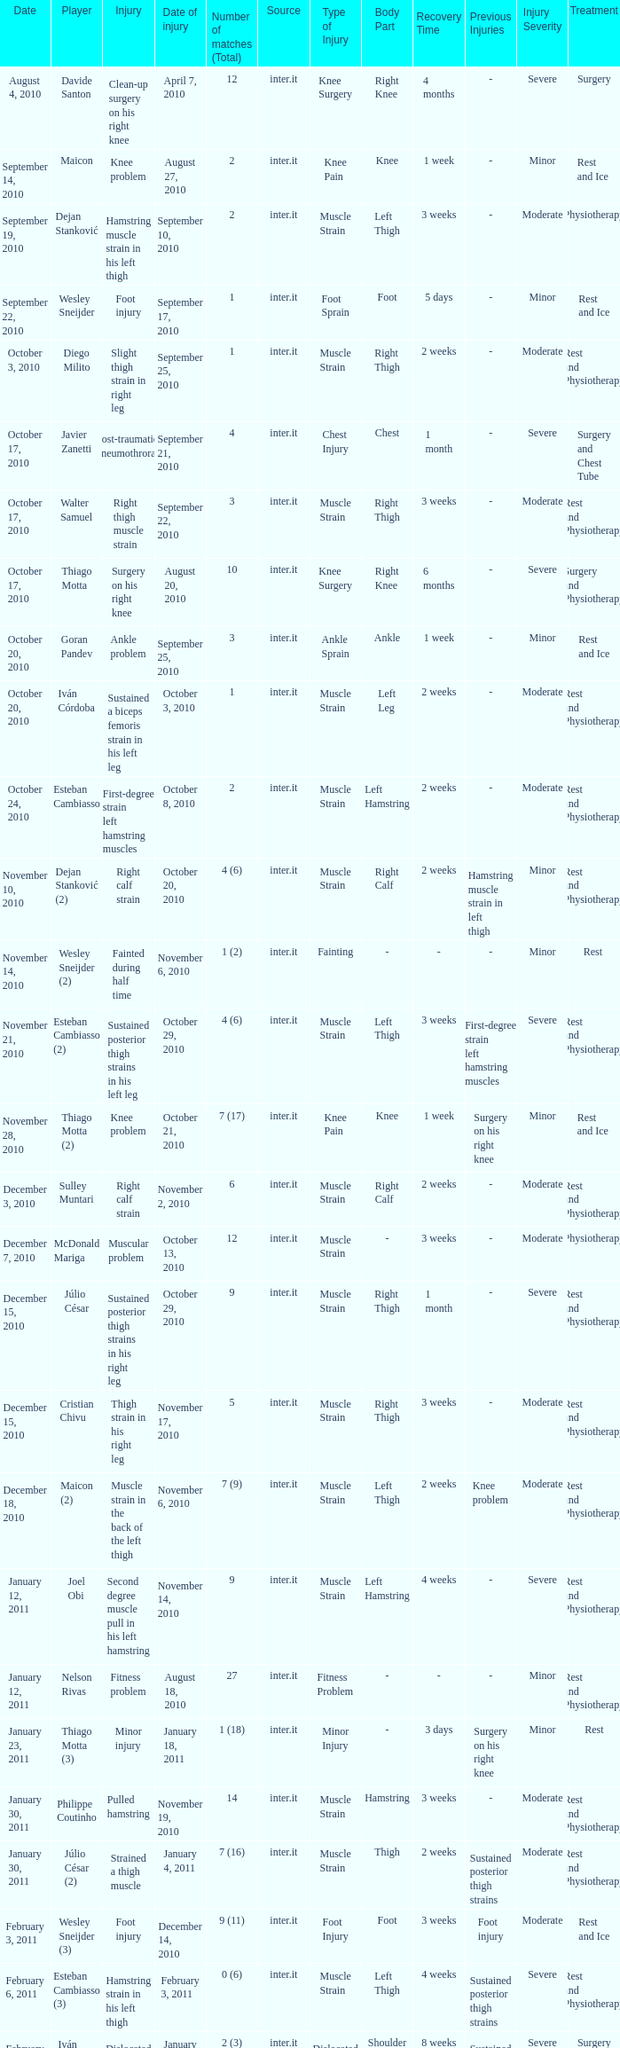What is the date of injury for player Wesley sneijder (2)? November 6, 2010. 